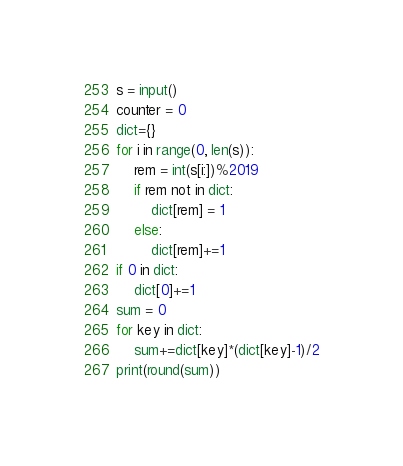<code> <loc_0><loc_0><loc_500><loc_500><_Python_>s = input()
counter = 0
dict={}
for i in range(0, len(s)):
    rem = int(s[i:])%2019
    if rem not in dict:
        dict[rem] = 1
    else:
        dict[rem]+=1
if 0 in dict:
    dict[0]+=1
sum = 0
for key in dict:
    sum+=dict[key]*(dict[key]-1)/2
print(round(sum))</code> 